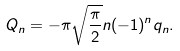Convert formula to latex. <formula><loc_0><loc_0><loc_500><loc_500>Q _ { n } = - \pi \sqrt { \frac { \pi } { 2 } } n ( - 1 ) ^ { n } q _ { n } .</formula> 